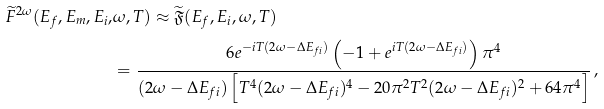<formula> <loc_0><loc_0><loc_500><loc_500>\widetilde { F } ^ { 2 \omega } ( E _ { f } , E _ { m } , E _ { i } , & \omega , T ) \approx \widetilde { \mathfrak { F } } ( E _ { f } , E _ { i } , \omega , T ) \\ & = \frac { 6 e ^ { - i T ( 2 \omega - \Delta E _ { f i } ) } \left ( - 1 + e ^ { i T ( 2 \omega - \Delta E _ { f i } ) } \right ) \pi ^ { 4 } } { ( 2 \omega - \Delta E _ { f i } ) \left [ T ^ { 4 } ( 2 \omega - \Delta E _ { f i } ) ^ { 4 } - 2 0 \pi ^ { 2 } T ^ { 2 } ( 2 \omega - \Delta E _ { f i } ) ^ { 2 } + 6 4 \pi ^ { 4 } \right ] } \, ,</formula> 